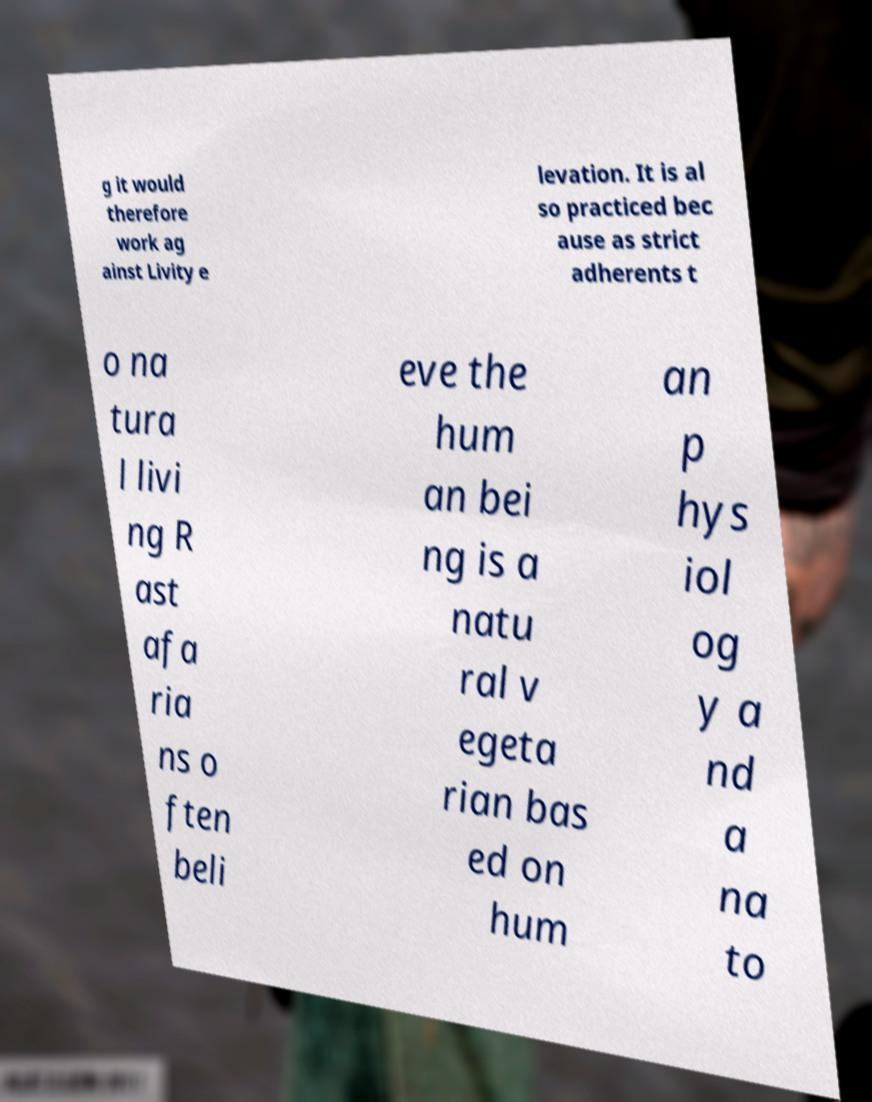Can you read and provide the text displayed in the image?This photo seems to have some interesting text. Can you extract and type it out for me? g it would therefore work ag ainst Livity e levation. It is al so practiced bec ause as strict adherents t o na tura l livi ng R ast afa ria ns o ften beli eve the hum an bei ng is a natu ral v egeta rian bas ed on hum an p hys iol og y a nd a na to 